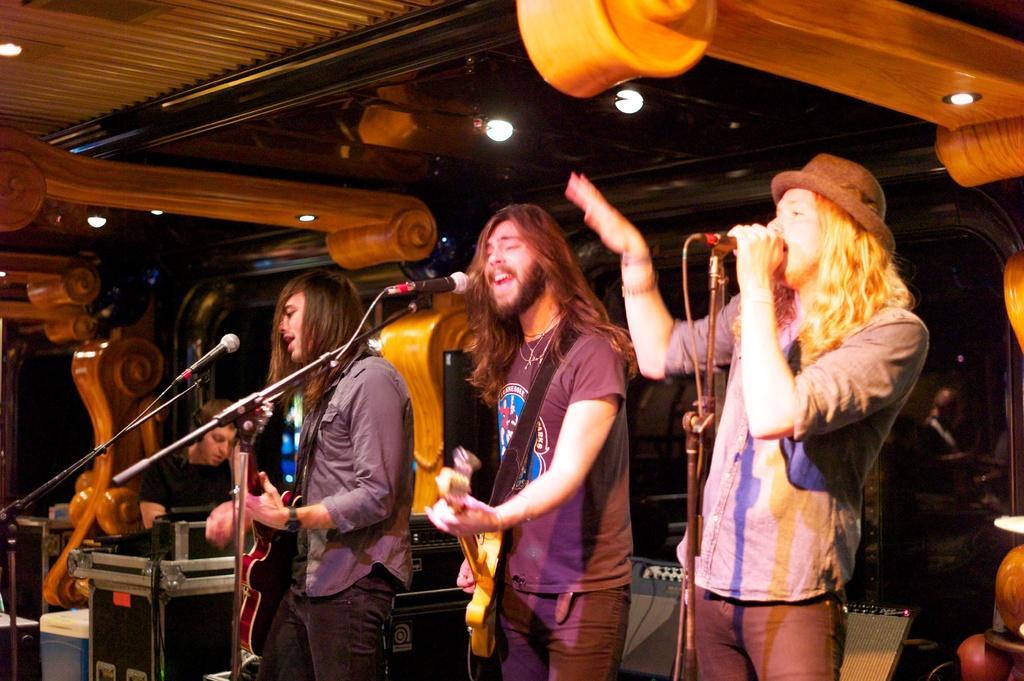Describe this image in one or two sentences. In this image i can see few people standing and holding musical instruments in their hands,I can see microphones in front of them. In the background i can see the ceiling and a person sitting. 